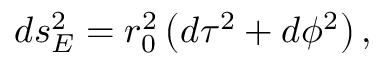<formula> <loc_0><loc_0><loc_500><loc_500>d s _ { E } ^ { 2 } = r _ { 0 } ^ { 2 } \left ( d \tau ^ { 2 } + d \phi ^ { 2 } \right ) ,</formula> 